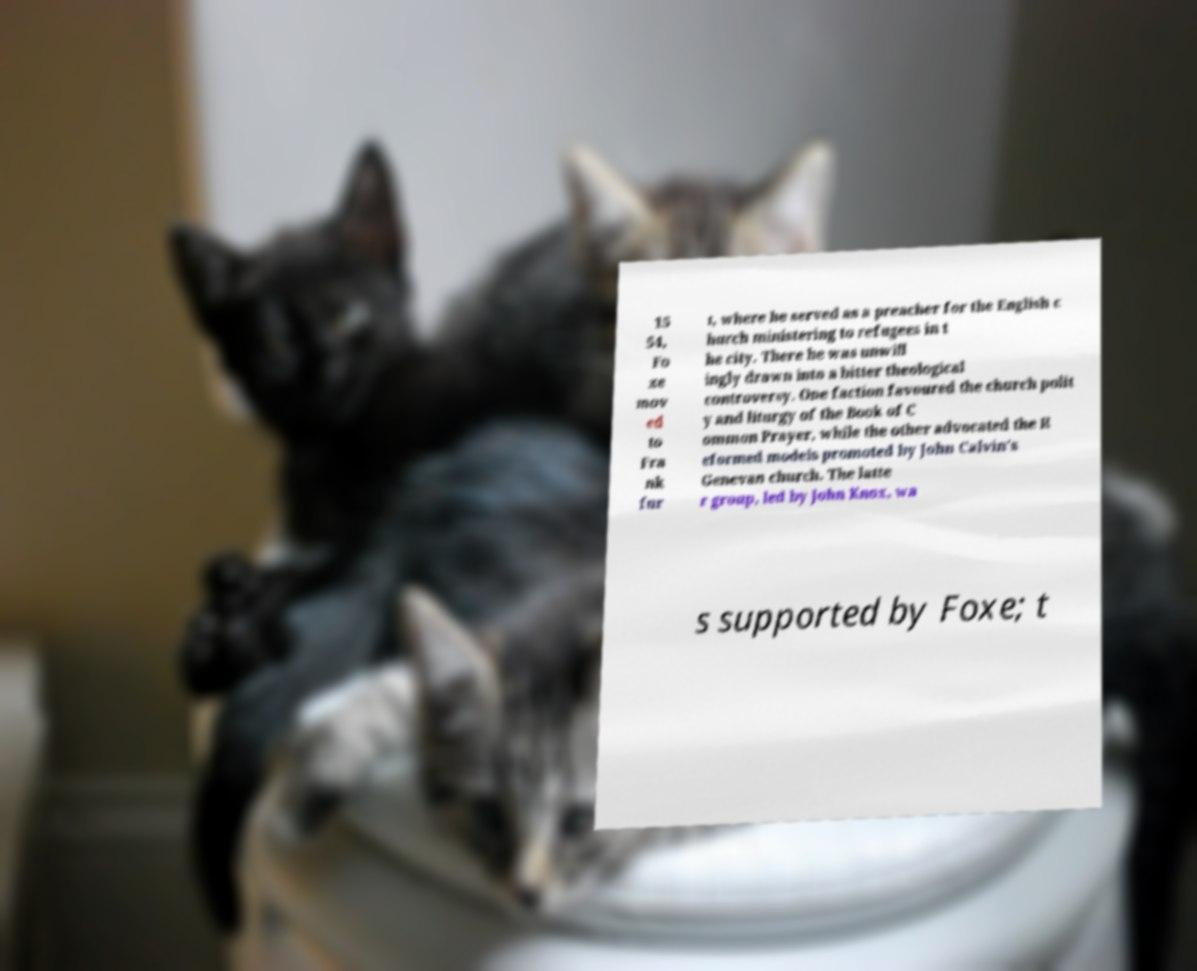There's text embedded in this image that I need extracted. Can you transcribe it verbatim? 15 54, Fo xe mov ed to Fra nk fur t, where he served as a preacher for the English c hurch ministering to refugees in t he city. There he was unwill ingly drawn into a bitter theological controversy. One faction favoured the church polit y and liturgy of the Book of C ommon Prayer, while the other advocated the R eformed models promoted by John Calvin's Genevan church. The latte r group, led by John Knox, wa s supported by Foxe; t 